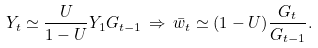Convert formula to latex. <formula><loc_0><loc_0><loc_500><loc_500>Y _ { t } \simeq \frac { U } { 1 - U } Y _ { 1 } G _ { t - 1 } \, \Rightarrow \, \bar { w } _ { t } \simeq ( 1 - U ) \frac { G _ { t } } { G _ { t - 1 } } .</formula> 